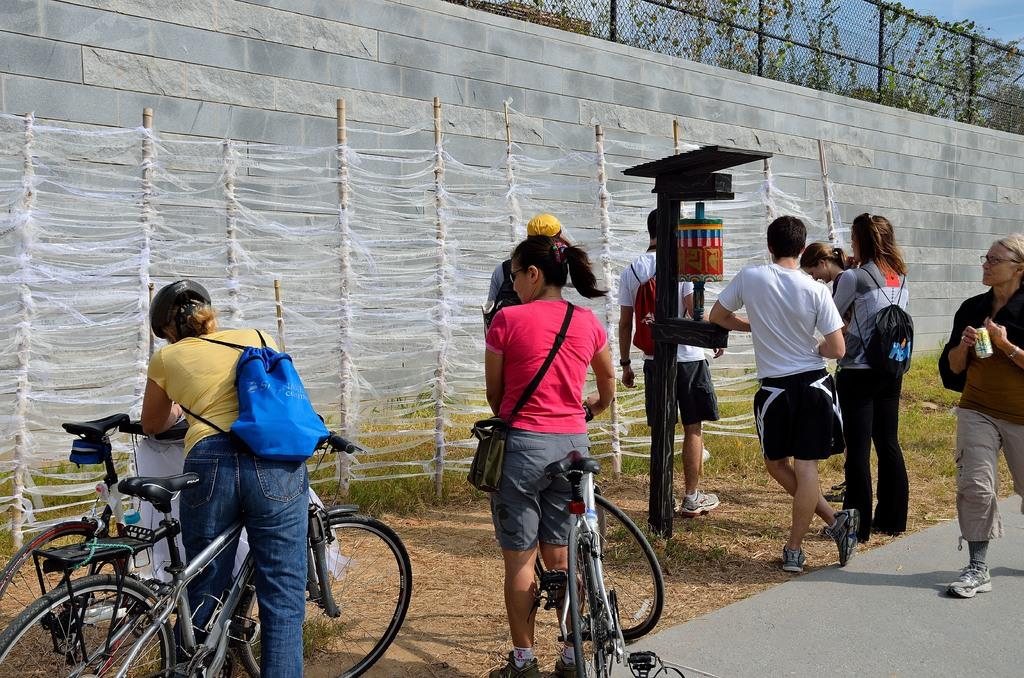What is happening in the image? There are people standing in the image. Can you describe the activity of the women in the image? The women are holding bicycles in the image. What type of flowers can be seen in the garden in the image? There is no garden present in the image, so it is not possible to determine what type of flowers might be seen. 